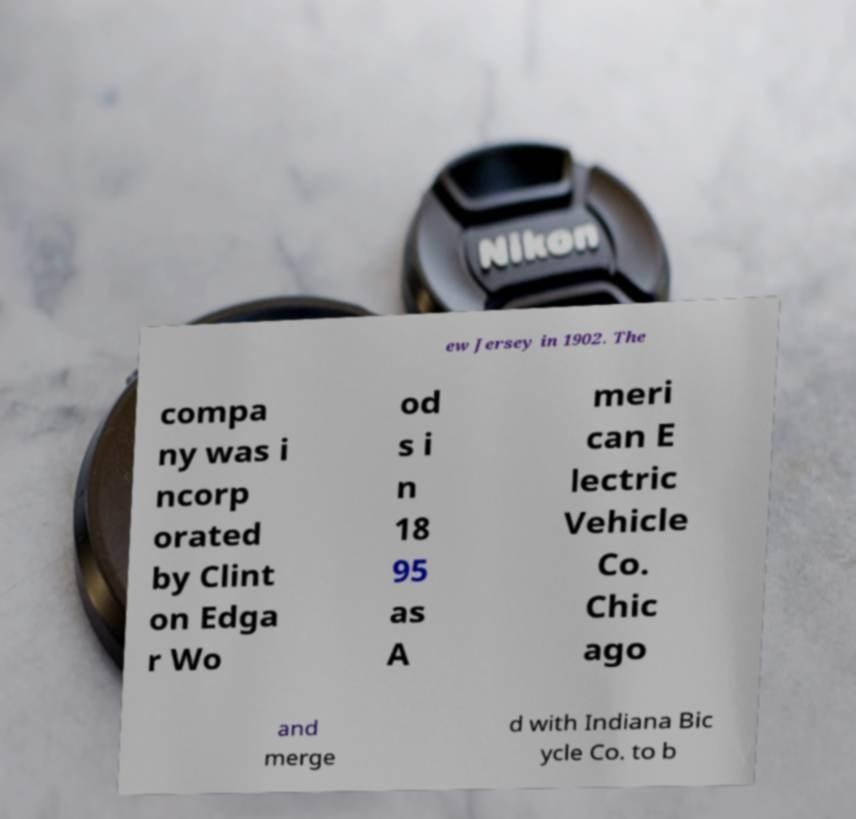There's text embedded in this image that I need extracted. Can you transcribe it verbatim? ew Jersey in 1902. The compa ny was i ncorp orated by Clint on Edga r Wo od s i n 18 95 as A meri can E lectric Vehicle Co. Chic ago and merge d with Indiana Bic ycle Co. to b 